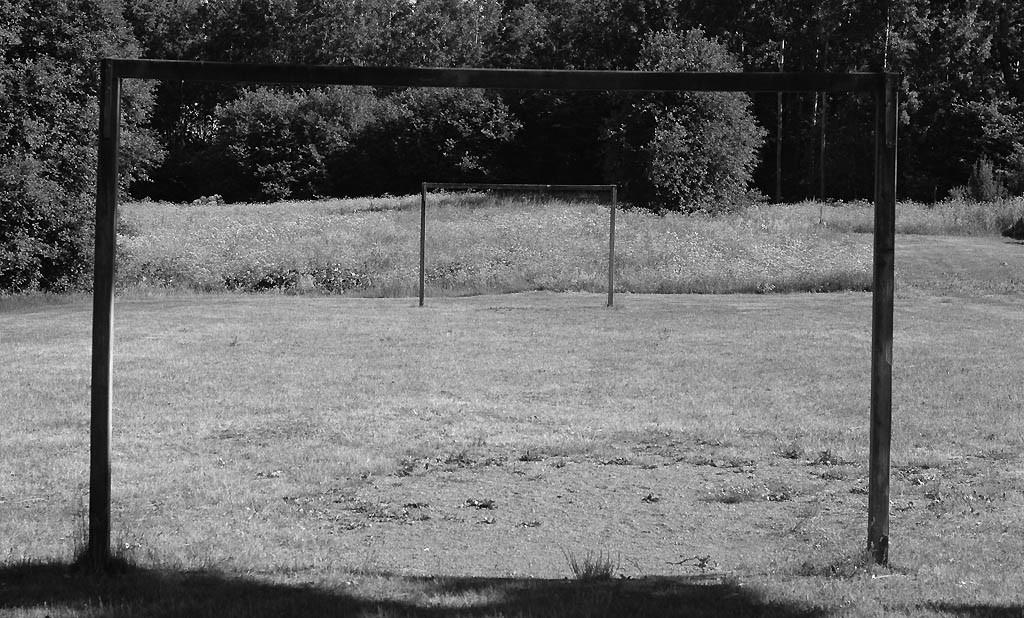What is the color scheme of the image? The image is black and white. What is the main subject in the front of the image? There is a goal post in the front of the image. What type of environment is visible in the background of the image? The grassland and trees are visible in the background of the image. Is there a stream visible in the image? There is no stream present in the image. What attempt is being made by the trees in the background? The trees in the background are not attempting anything; they are simply standing in the image. 